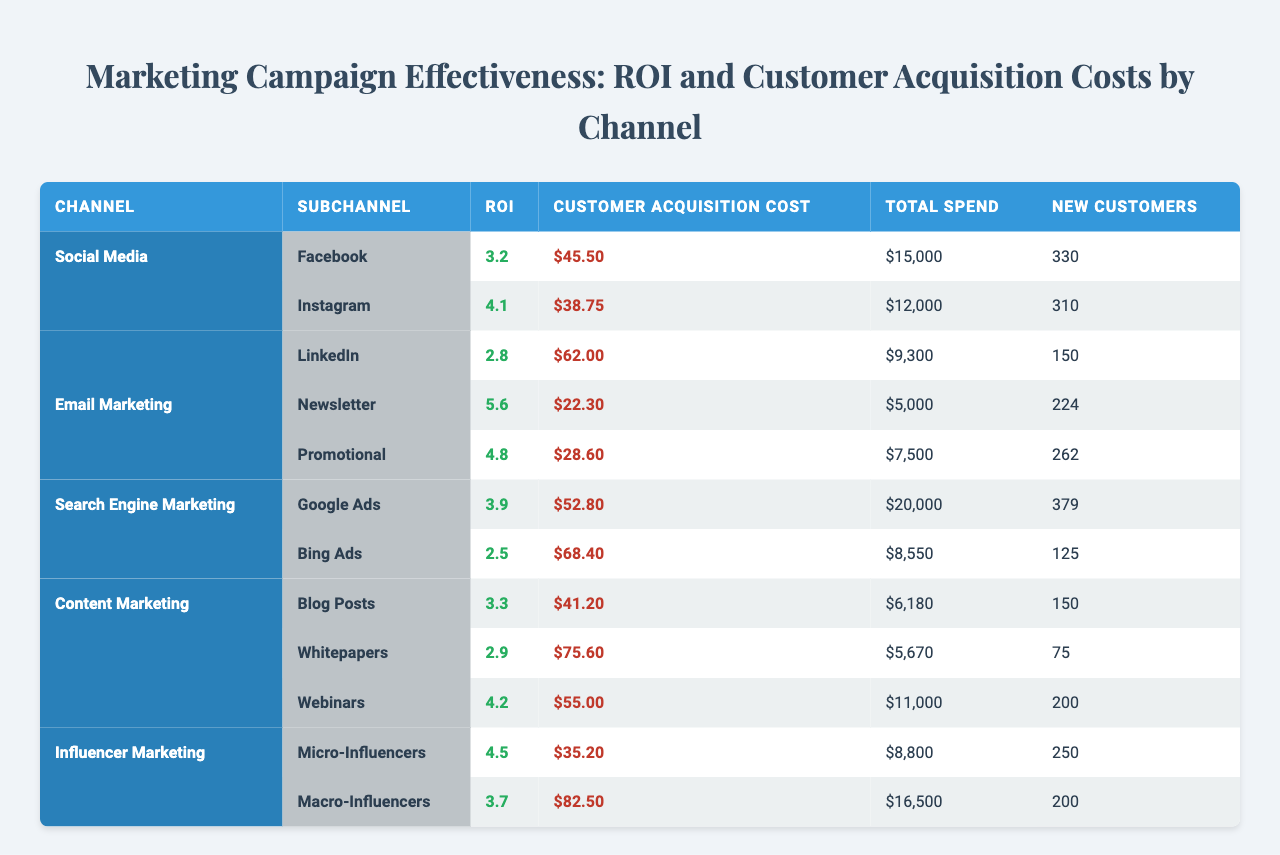What is the ROI for Instagram? The table shows that the ROI listed for Instagram is 4.1.
Answer: 4.1 Which channel has the highest customer acquisition cost? Reviewing the customer acquisition costs, LinkedIn has the highest value at $62.00.
Answer: $62.00 How much was spent on Google Ads? The table indicates that $20,000 was spent on Google Ads in the Search Engine Marketing channel.
Answer: $20,000 What are the total new customers acquired from Email Marketing? For Email Marketing, the total new customers can be found by summing the new customers from both campaigns: 224 (Newsletter) + 262 (Promotional) = 486.
Answer: 486 Which platform under Social Media had the lowest customer acquisition cost? Looking at the customer acquisition costs under Social Media, Instagram has the lowest cost at $38.75.
Answer: $38.75 What is the average ROI for the Content Marketing types? The ROIs for Blog Posts (3.3), Whitepapers (2.9), and Webinars (4.2) are summed (3.3 + 2.9 + 4.2 = 10.4) and divided by 3 to find the average: 10.4 / 3 = 3.47.
Answer: 3.47 Is it true that Macro-Influencers had a higher total spend than Micro-Influencers? Yes, Macro-Influencers had a total spend of $16,500, which is greater than the $8,800 spent on Micro-Influencers.
Answer: Yes What is the difference in total spend between the best-performing Email Marketing campaign and the worst-performing one? The best-performing campaign (Newsletter) had a total spend of $5,000, while the worst-performing one (Promotional) had $7,500. Thus, the difference is $7,500 - $5,000 = $2,500.
Answer: $2,500 Which channel had the highest ROI overall? By reviewing the ROI values: Social Media has max ROI of 4.1 (Instagram), Email Marketing has 5.6 (Newsletter), Content Marketing has max 4.2 (Webinars), and Influencer Marketing has 4.5 (Micro-Influencers). The Email Marketing channel holds the highest ROI at 5.6.
Answer: 5.6 How many total new customers were acquired across all platforms? Summing the new customers for all platforms gives: 330 (Facebook) + 310 (Instagram) + 150 (LinkedIn) + 224 (Newsletter) + 262 (Promotional) + 379 (Google Ads) + 125 (Bing Ads) + 150 (Blog Posts) + 75 (Whitepapers) + 200 (Webinars) + 250 (Micro-Influencers) + 200 (Macro-Influencers) equals 2,060.
Answer: 2060 